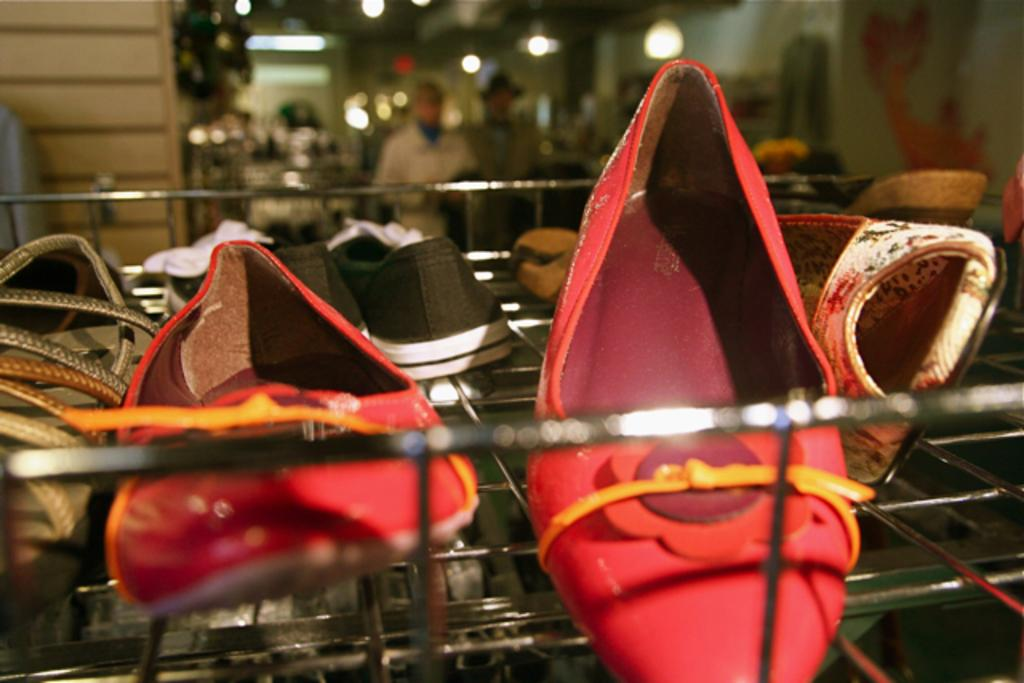What objects are placed on a rack in the image? There are shoes placed on a rack in the image. What are the persons in the image doing? The persons are standing on the floor in the image. What can be seen in the background of the image? There are electric lights and walls in the background of the image. How does the wind affect the part of the image where the shoes are placed? There is no wind present in the image, so it cannot affect the placement of the shoes on the rack. What is the birth rate of the persons in the image? The image does not provide information about the birth rate of the persons, as it only shows them standing on the floor. 